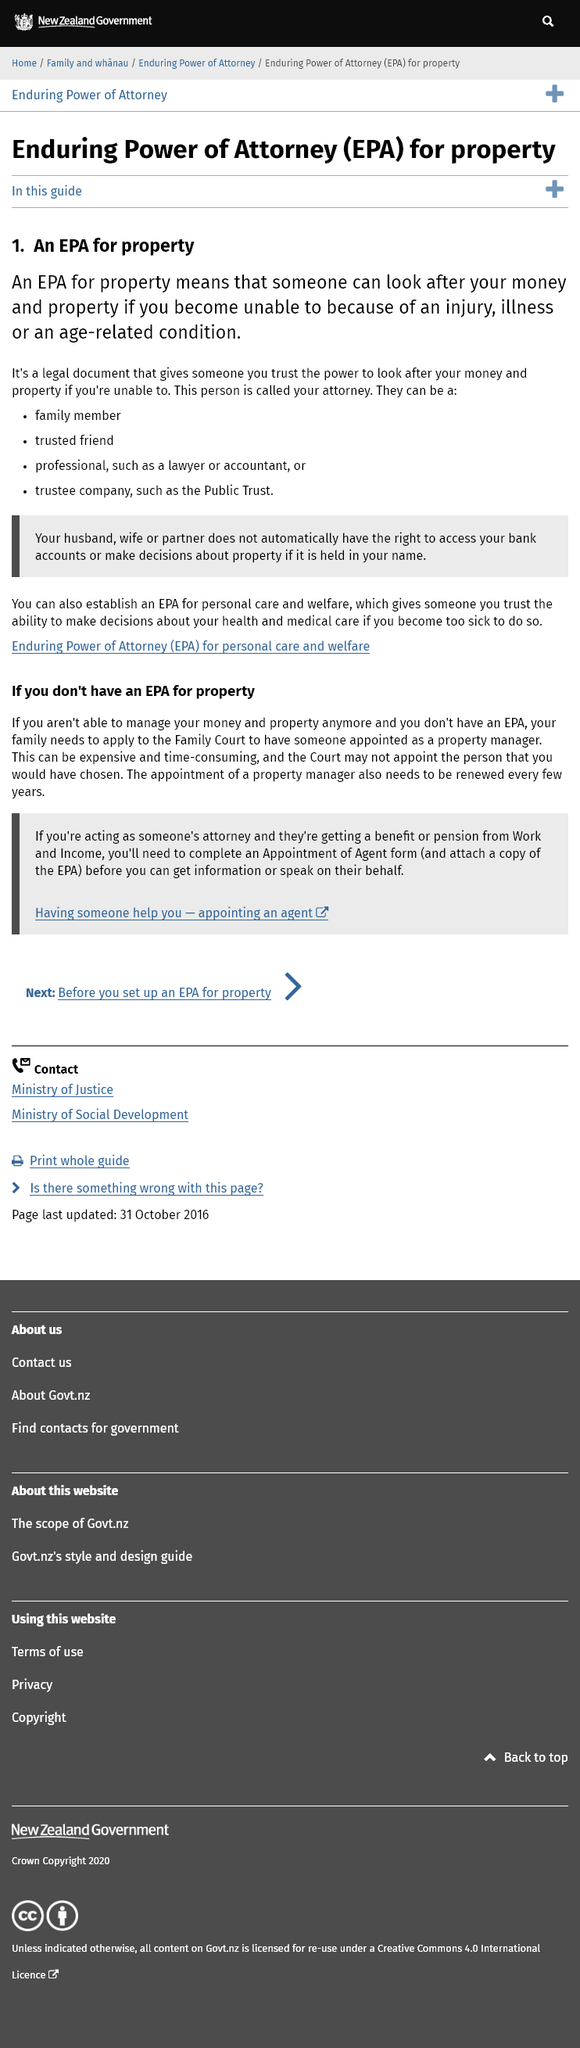Mention a couple of crucial points in this snapshot. If you are acting as someone's attorney and they are receiving a benefit or pension from Work and Income, you must complete an Appointment of Agent form in order to legally represent them and assist them with their financial benefits. Enduring Power of Attorney" is what EPA stands for. If you are unable to manage your own money and property and do not have an Enduring Power of Attorney in place, you are required to apply to the Family Court for a Property Manager to be appointed to manage your affairs on your behalf. Yes, a trusted friend can serve as your attorney. Yes, it is possible to establish an Environmental Protection Agency (EPA) to oversee personal care and welfare. 